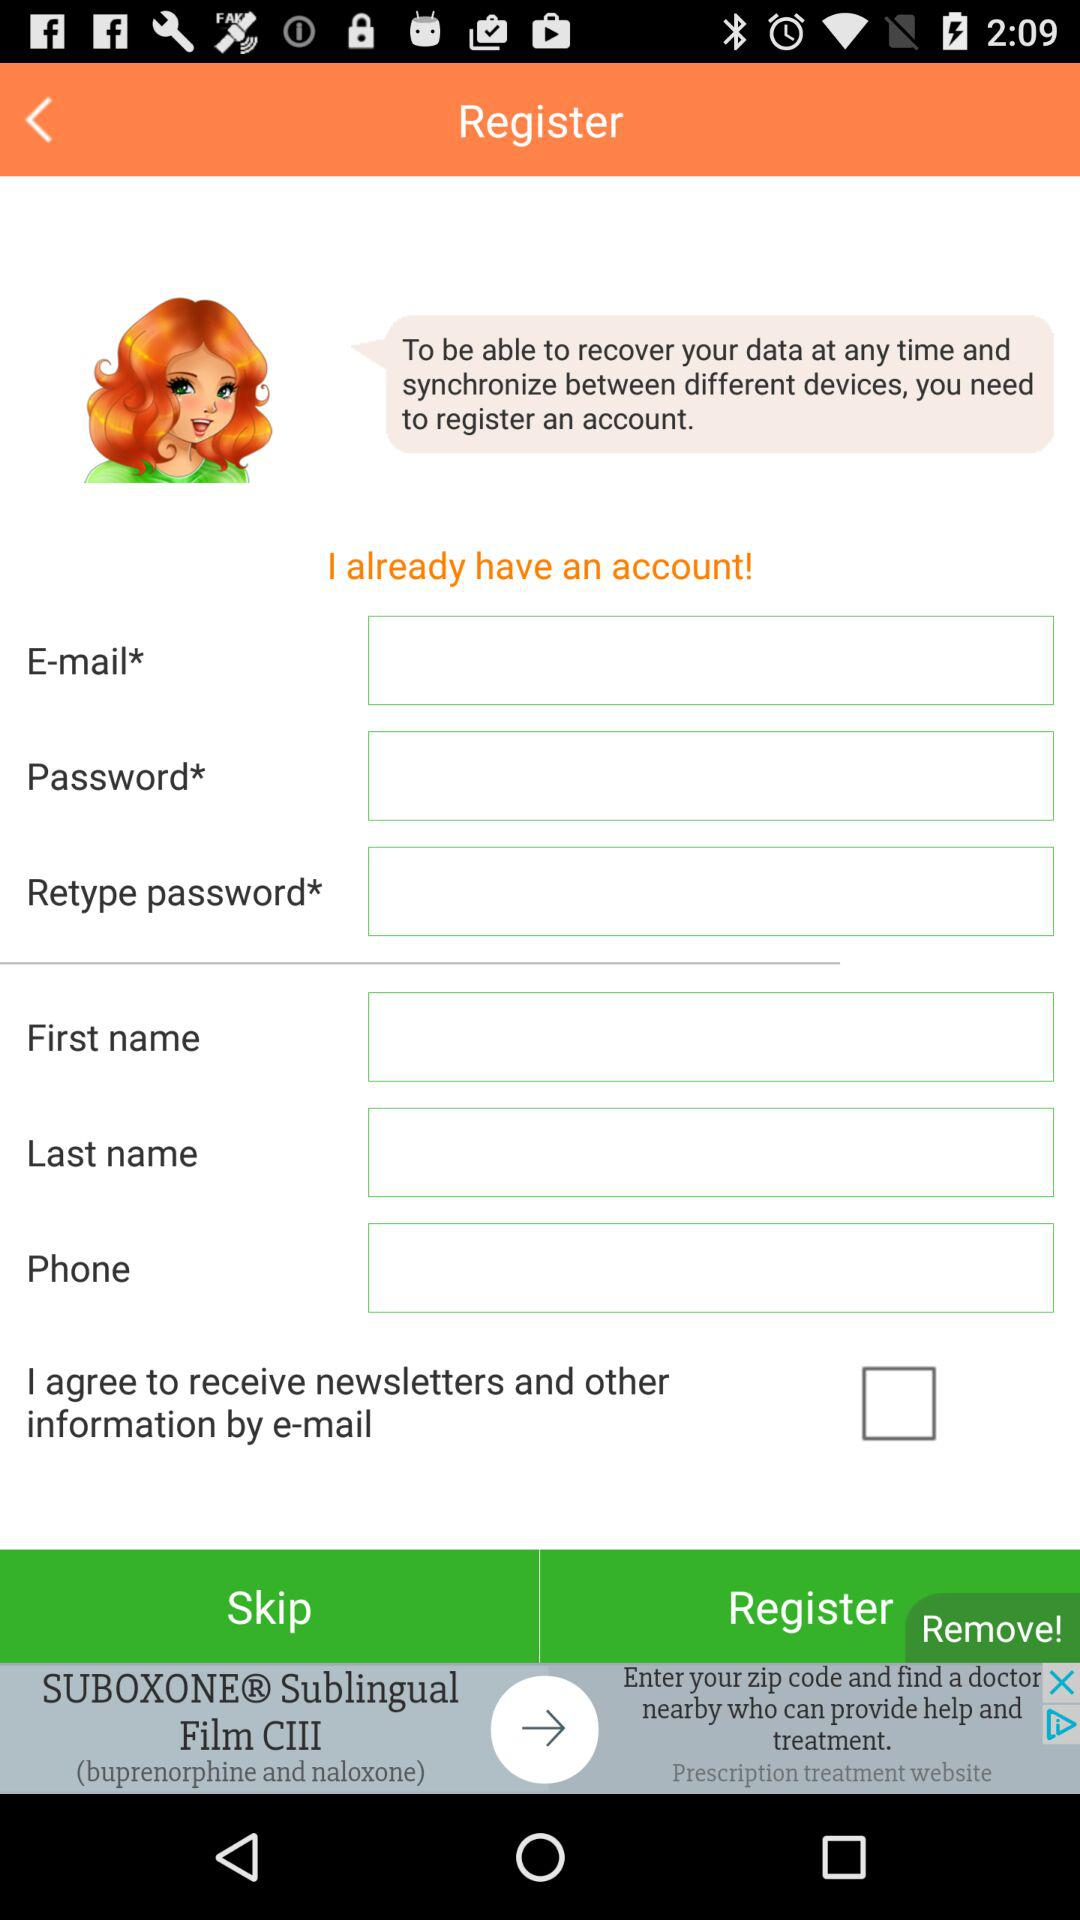How many text inputs require an asterisk?
Answer the question using a single word or phrase. 3 